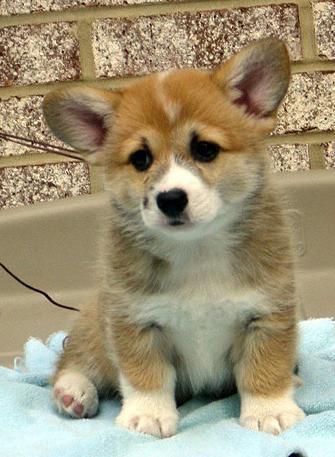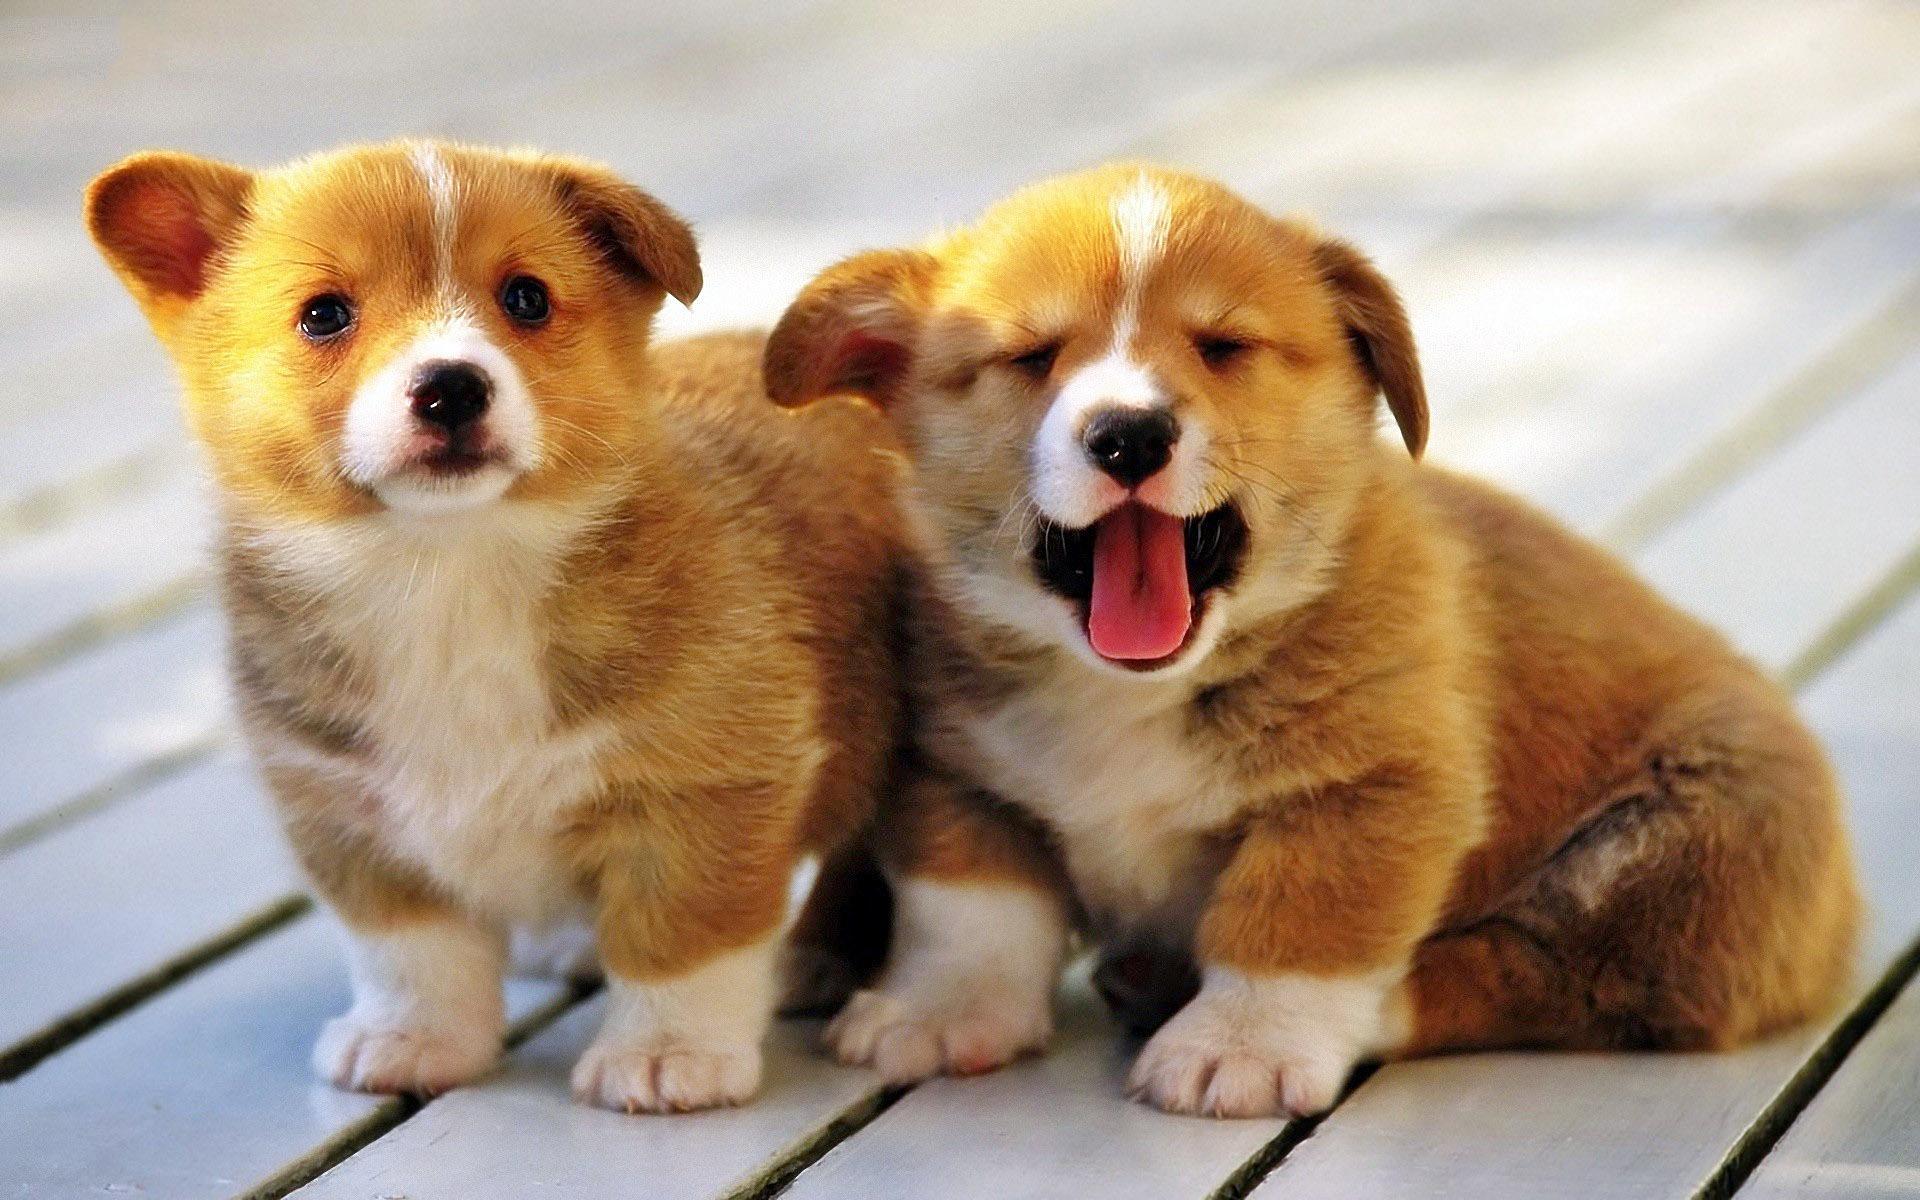The first image is the image on the left, the second image is the image on the right. For the images displayed, is the sentence "There is exactly three puppies." factually correct? Answer yes or no. Yes. The first image is the image on the left, the second image is the image on the right. Given the left and right images, does the statement "The righthand image contains a single dog, which is tri-colored and sitting upright, with its mouth closed." hold true? Answer yes or no. No. 